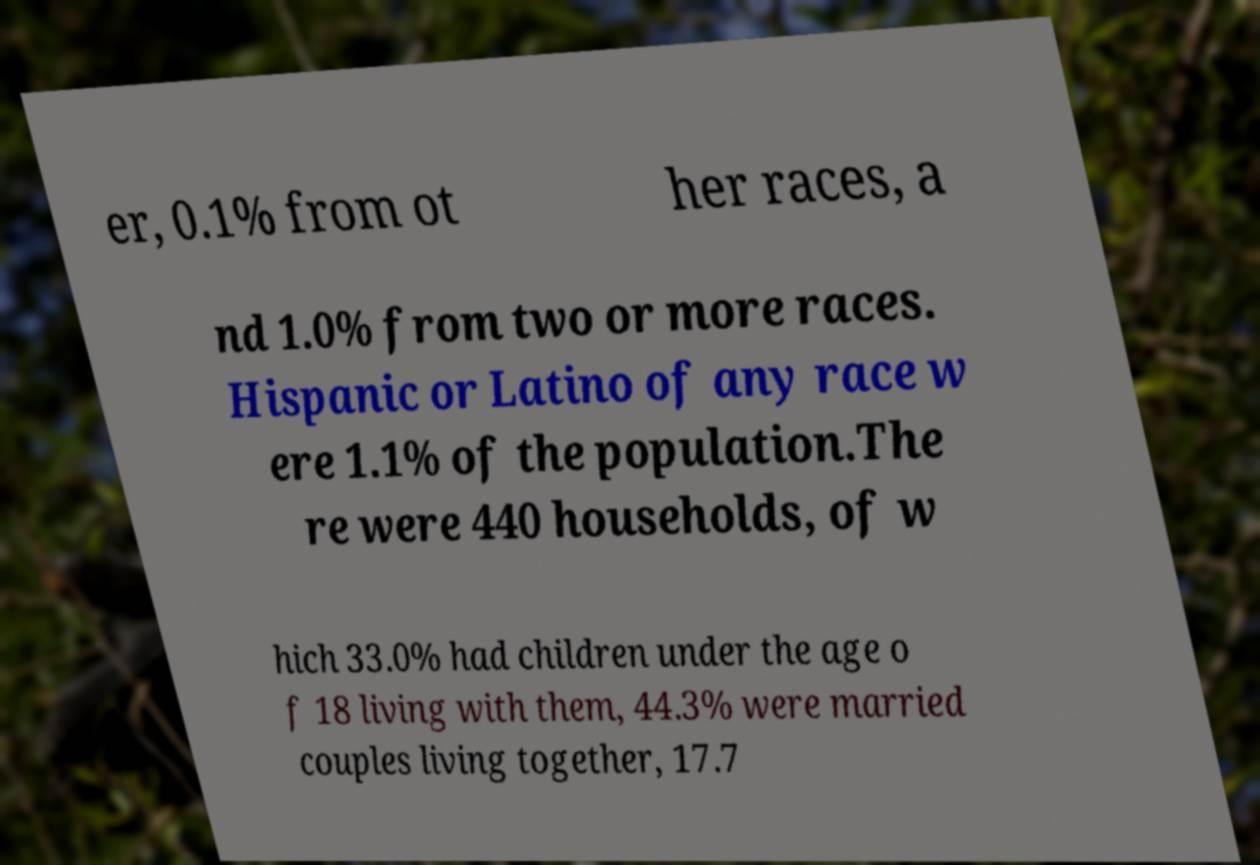Could you extract and type out the text from this image? er, 0.1% from ot her races, a nd 1.0% from two or more races. Hispanic or Latino of any race w ere 1.1% of the population.The re were 440 households, of w hich 33.0% had children under the age o f 18 living with them, 44.3% were married couples living together, 17.7 